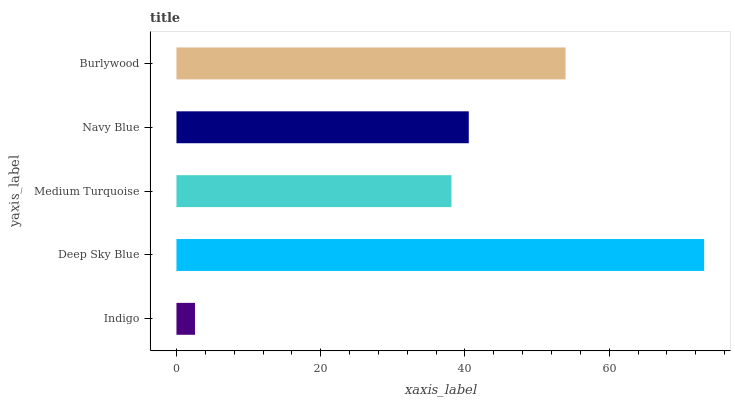Is Indigo the minimum?
Answer yes or no. Yes. Is Deep Sky Blue the maximum?
Answer yes or no. Yes. Is Medium Turquoise the minimum?
Answer yes or no. No. Is Medium Turquoise the maximum?
Answer yes or no. No. Is Deep Sky Blue greater than Medium Turquoise?
Answer yes or no. Yes. Is Medium Turquoise less than Deep Sky Blue?
Answer yes or no. Yes. Is Medium Turquoise greater than Deep Sky Blue?
Answer yes or no. No. Is Deep Sky Blue less than Medium Turquoise?
Answer yes or no. No. Is Navy Blue the high median?
Answer yes or no. Yes. Is Navy Blue the low median?
Answer yes or no. Yes. Is Burlywood the high median?
Answer yes or no. No. Is Deep Sky Blue the low median?
Answer yes or no. No. 